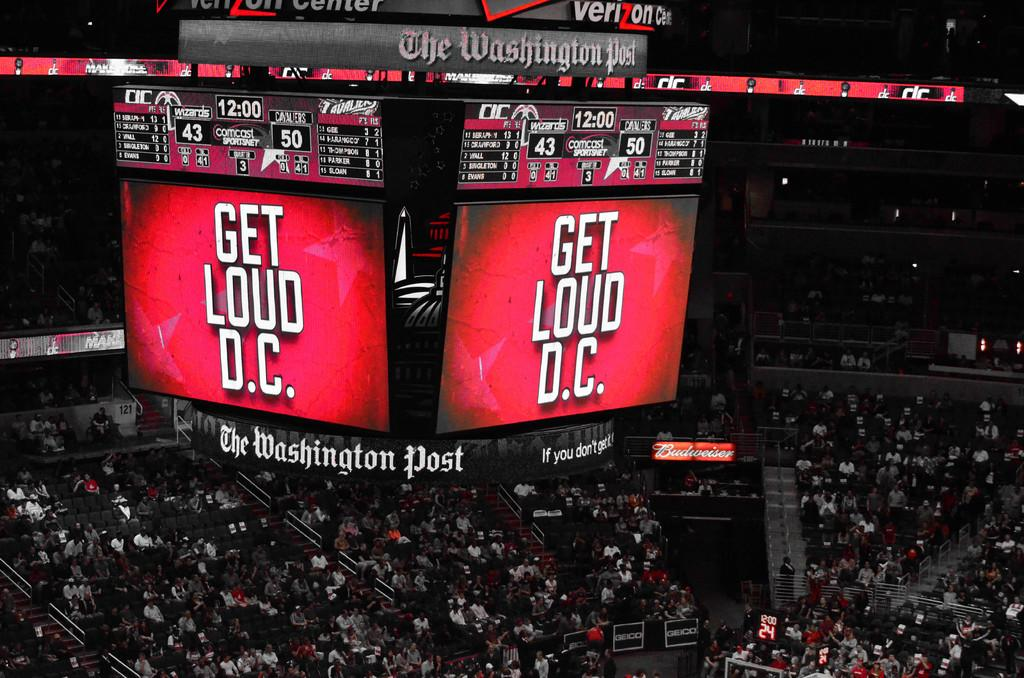<image>
Render a clear and concise summary of the photo. Spectators at a game between the Wizards and Cavaliers in the Verizon Center stadium 